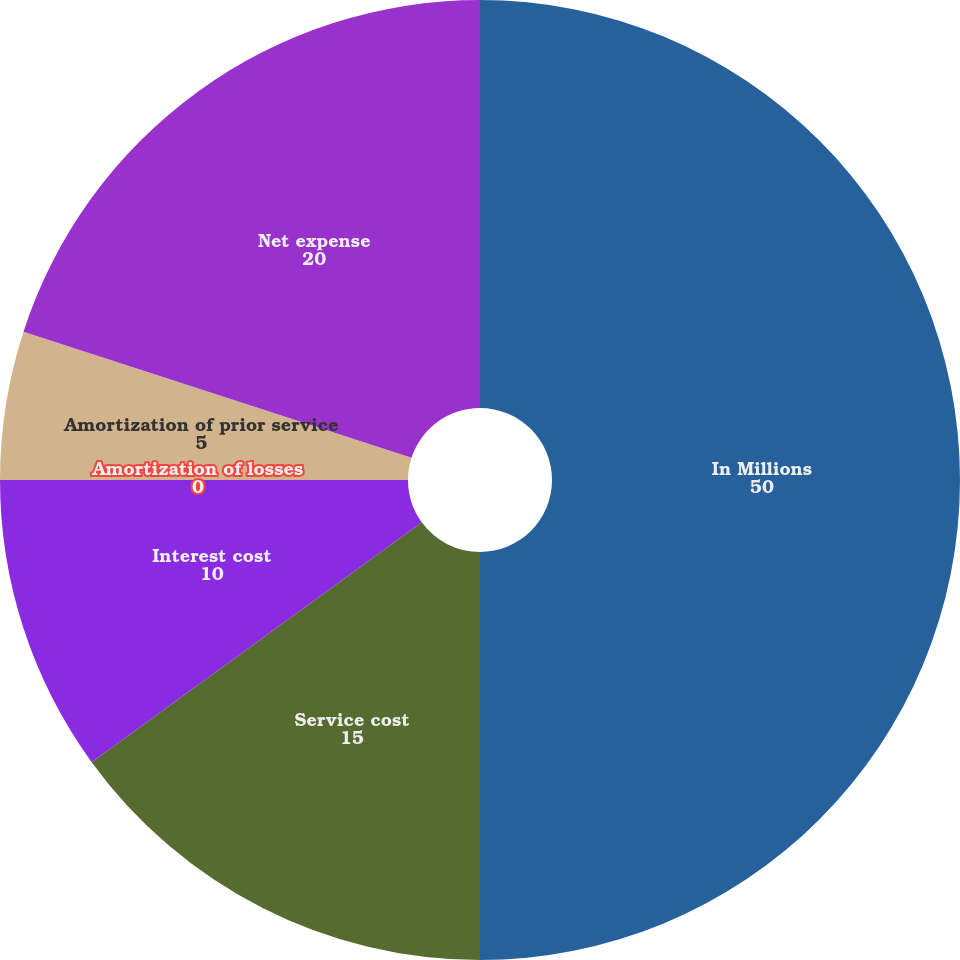Convert chart to OTSL. <chart><loc_0><loc_0><loc_500><loc_500><pie_chart><fcel>In Millions<fcel>Service cost<fcel>Interest cost<fcel>Amortization of losses<fcel>Amortization of prior service<fcel>Net expense<nl><fcel>50.0%<fcel>15.0%<fcel>10.0%<fcel>0.0%<fcel>5.0%<fcel>20.0%<nl></chart> 